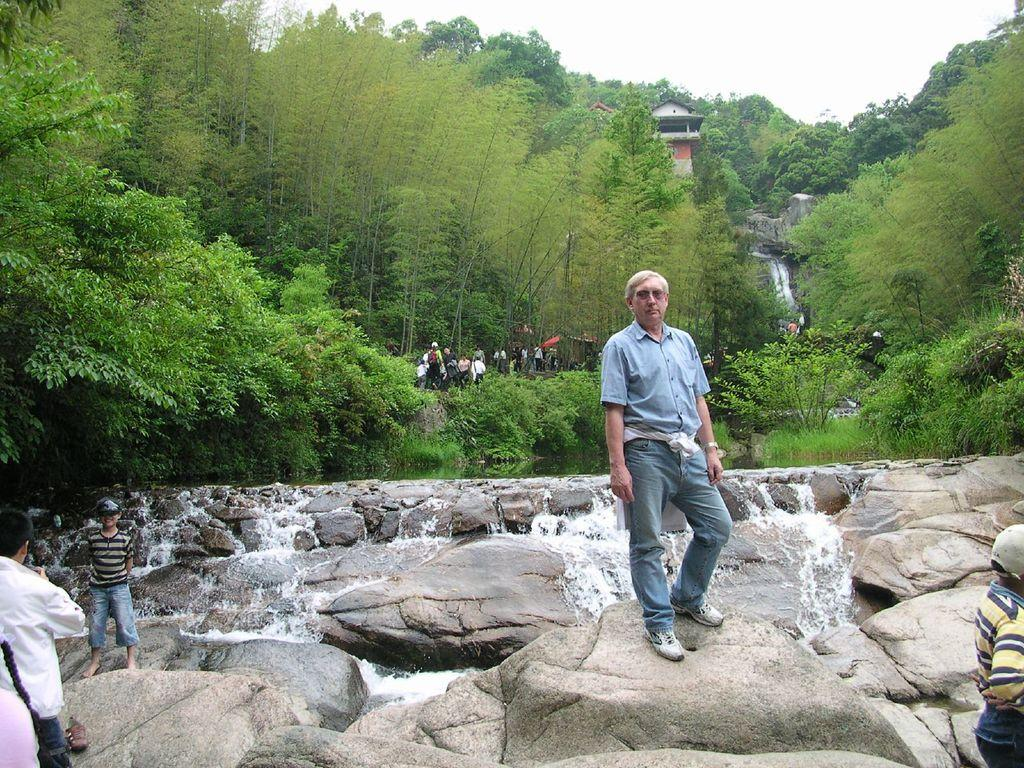How many people are in the image? There is a group of people in the image, but the exact number cannot be determined from the provided facts. What can be seen in the background of the image? There are trees and the sky visible in the background of the image. What type of butter is being used by the people in the image? There is no butter present in the image; it features a group of people and a background with trees and the sky. 